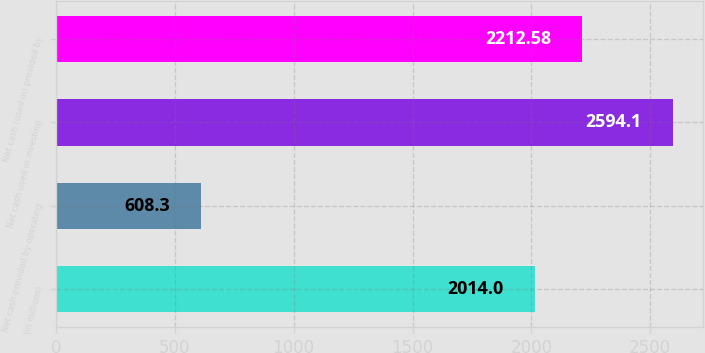Convert chart. <chart><loc_0><loc_0><loc_500><loc_500><bar_chart><fcel>(in millions)<fcel>Net cash provided by operating<fcel>Net cash used in investing<fcel>Net cash (used in) provided by<nl><fcel>2014<fcel>608.3<fcel>2594.1<fcel>2212.58<nl></chart> 